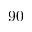<formula> <loc_0><loc_0><loc_500><loc_500>9 0</formula> 